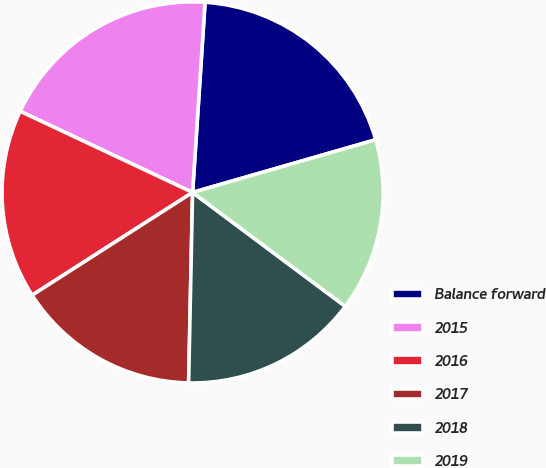Convert chart. <chart><loc_0><loc_0><loc_500><loc_500><pie_chart><fcel>Balance forward<fcel>2015<fcel>2016<fcel>2017<fcel>2018<fcel>2019<nl><fcel>19.5%<fcel>19.04%<fcel>16.07%<fcel>15.6%<fcel>15.13%<fcel>14.66%<nl></chart> 